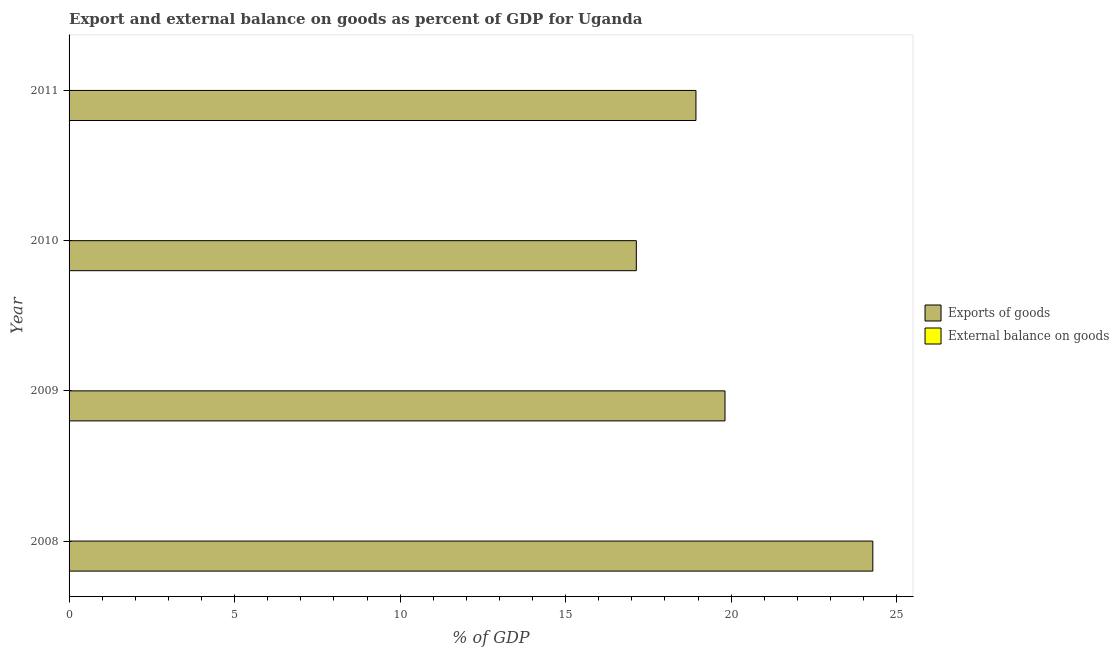How many different coloured bars are there?
Give a very brief answer. 1. Are the number of bars per tick equal to the number of legend labels?
Make the answer very short. No. How many bars are there on the 1st tick from the top?
Make the answer very short. 1. How many bars are there on the 1st tick from the bottom?
Keep it short and to the point. 1. What is the export of goods as percentage of gdp in 2009?
Your response must be concise. 19.81. Across all years, what is the maximum export of goods as percentage of gdp?
Offer a terse response. 24.28. Across all years, what is the minimum external balance on goods as percentage of gdp?
Provide a short and direct response. 0. What is the total export of goods as percentage of gdp in the graph?
Provide a succinct answer. 80.17. What is the difference between the export of goods as percentage of gdp in 2009 and that in 2010?
Your answer should be compact. 2.68. What is the difference between the export of goods as percentage of gdp in 2009 and the external balance on goods as percentage of gdp in 2010?
Offer a terse response. 19.81. In how many years, is the external balance on goods as percentage of gdp greater than 12 %?
Your answer should be very brief. 0. What is the ratio of the export of goods as percentage of gdp in 2008 to that in 2010?
Offer a terse response. 1.42. What is the difference between the highest and the second highest export of goods as percentage of gdp?
Ensure brevity in your answer.  4.47. What is the difference between the highest and the lowest export of goods as percentage of gdp?
Give a very brief answer. 7.14. In how many years, is the export of goods as percentage of gdp greater than the average export of goods as percentage of gdp taken over all years?
Give a very brief answer. 1. Is the sum of the export of goods as percentage of gdp in 2009 and 2010 greater than the maximum external balance on goods as percentage of gdp across all years?
Keep it short and to the point. Yes. How many bars are there?
Your response must be concise. 4. How many years are there in the graph?
Keep it short and to the point. 4. What is the difference between two consecutive major ticks on the X-axis?
Offer a terse response. 5. Where does the legend appear in the graph?
Offer a terse response. Center right. How are the legend labels stacked?
Your response must be concise. Vertical. What is the title of the graph?
Make the answer very short. Export and external balance on goods as percent of GDP for Uganda. What is the label or title of the X-axis?
Ensure brevity in your answer.  % of GDP. What is the label or title of the Y-axis?
Your answer should be very brief. Year. What is the % of GDP in Exports of goods in 2008?
Offer a terse response. 24.28. What is the % of GDP of External balance on goods in 2008?
Make the answer very short. 0. What is the % of GDP in Exports of goods in 2009?
Provide a succinct answer. 19.81. What is the % of GDP of External balance on goods in 2009?
Your response must be concise. 0. What is the % of GDP in Exports of goods in 2010?
Keep it short and to the point. 17.14. What is the % of GDP of External balance on goods in 2010?
Provide a short and direct response. 0. What is the % of GDP of Exports of goods in 2011?
Offer a terse response. 18.94. Across all years, what is the maximum % of GDP in Exports of goods?
Offer a very short reply. 24.28. Across all years, what is the minimum % of GDP of Exports of goods?
Provide a short and direct response. 17.14. What is the total % of GDP in Exports of goods in the graph?
Keep it short and to the point. 80.17. What is the difference between the % of GDP in Exports of goods in 2008 and that in 2009?
Keep it short and to the point. 4.47. What is the difference between the % of GDP of Exports of goods in 2008 and that in 2010?
Offer a terse response. 7.14. What is the difference between the % of GDP of Exports of goods in 2008 and that in 2011?
Your answer should be compact. 5.34. What is the difference between the % of GDP of Exports of goods in 2009 and that in 2010?
Provide a succinct answer. 2.68. What is the difference between the % of GDP in Exports of goods in 2009 and that in 2011?
Ensure brevity in your answer.  0.88. What is the difference between the % of GDP of Exports of goods in 2010 and that in 2011?
Provide a succinct answer. -1.8. What is the average % of GDP of Exports of goods per year?
Provide a succinct answer. 20.04. What is the ratio of the % of GDP in Exports of goods in 2008 to that in 2009?
Keep it short and to the point. 1.23. What is the ratio of the % of GDP in Exports of goods in 2008 to that in 2010?
Keep it short and to the point. 1.42. What is the ratio of the % of GDP in Exports of goods in 2008 to that in 2011?
Your answer should be very brief. 1.28. What is the ratio of the % of GDP in Exports of goods in 2009 to that in 2010?
Give a very brief answer. 1.16. What is the ratio of the % of GDP of Exports of goods in 2009 to that in 2011?
Your response must be concise. 1.05. What is the ratio of the % of GDP in Exports of goods in 2010 to that in 2011?
Offer a terse response. 0.9. What is the difference between the highest and the second highest % of GDP in Exports of goods?
Your answer should be very brief. 4.47. What is the difference between the highest and the lowest % of GDP of Exports of goods?
Offer a very short reply. 7.14. 